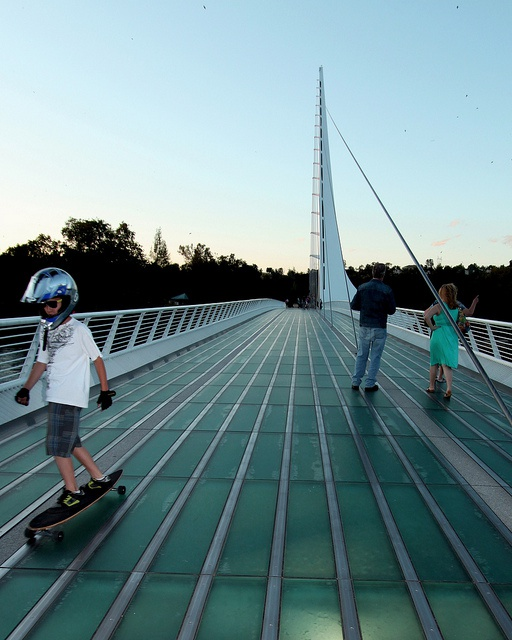Describe the objects in this image and their specific colors. I can see people in lightblue, black, gray, and lightgray tones, people in lightblue, black, blue, darkblue, and teal tones, people in lightblue, teal, black, and gray tones, skateboard in lightblue, black, gray, and maroon tones, and people in lightblue, black, maroon, gray, and darkblue tones in this image. 